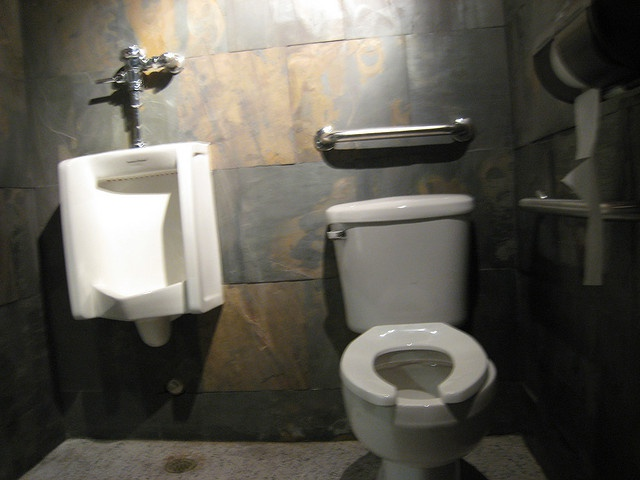Describe the objects in this image and their specific colors. I can see toilet in black, gray, darkgray, and darkgreen tones and toilet in black, white, darkgray, and gray tones in this image. 